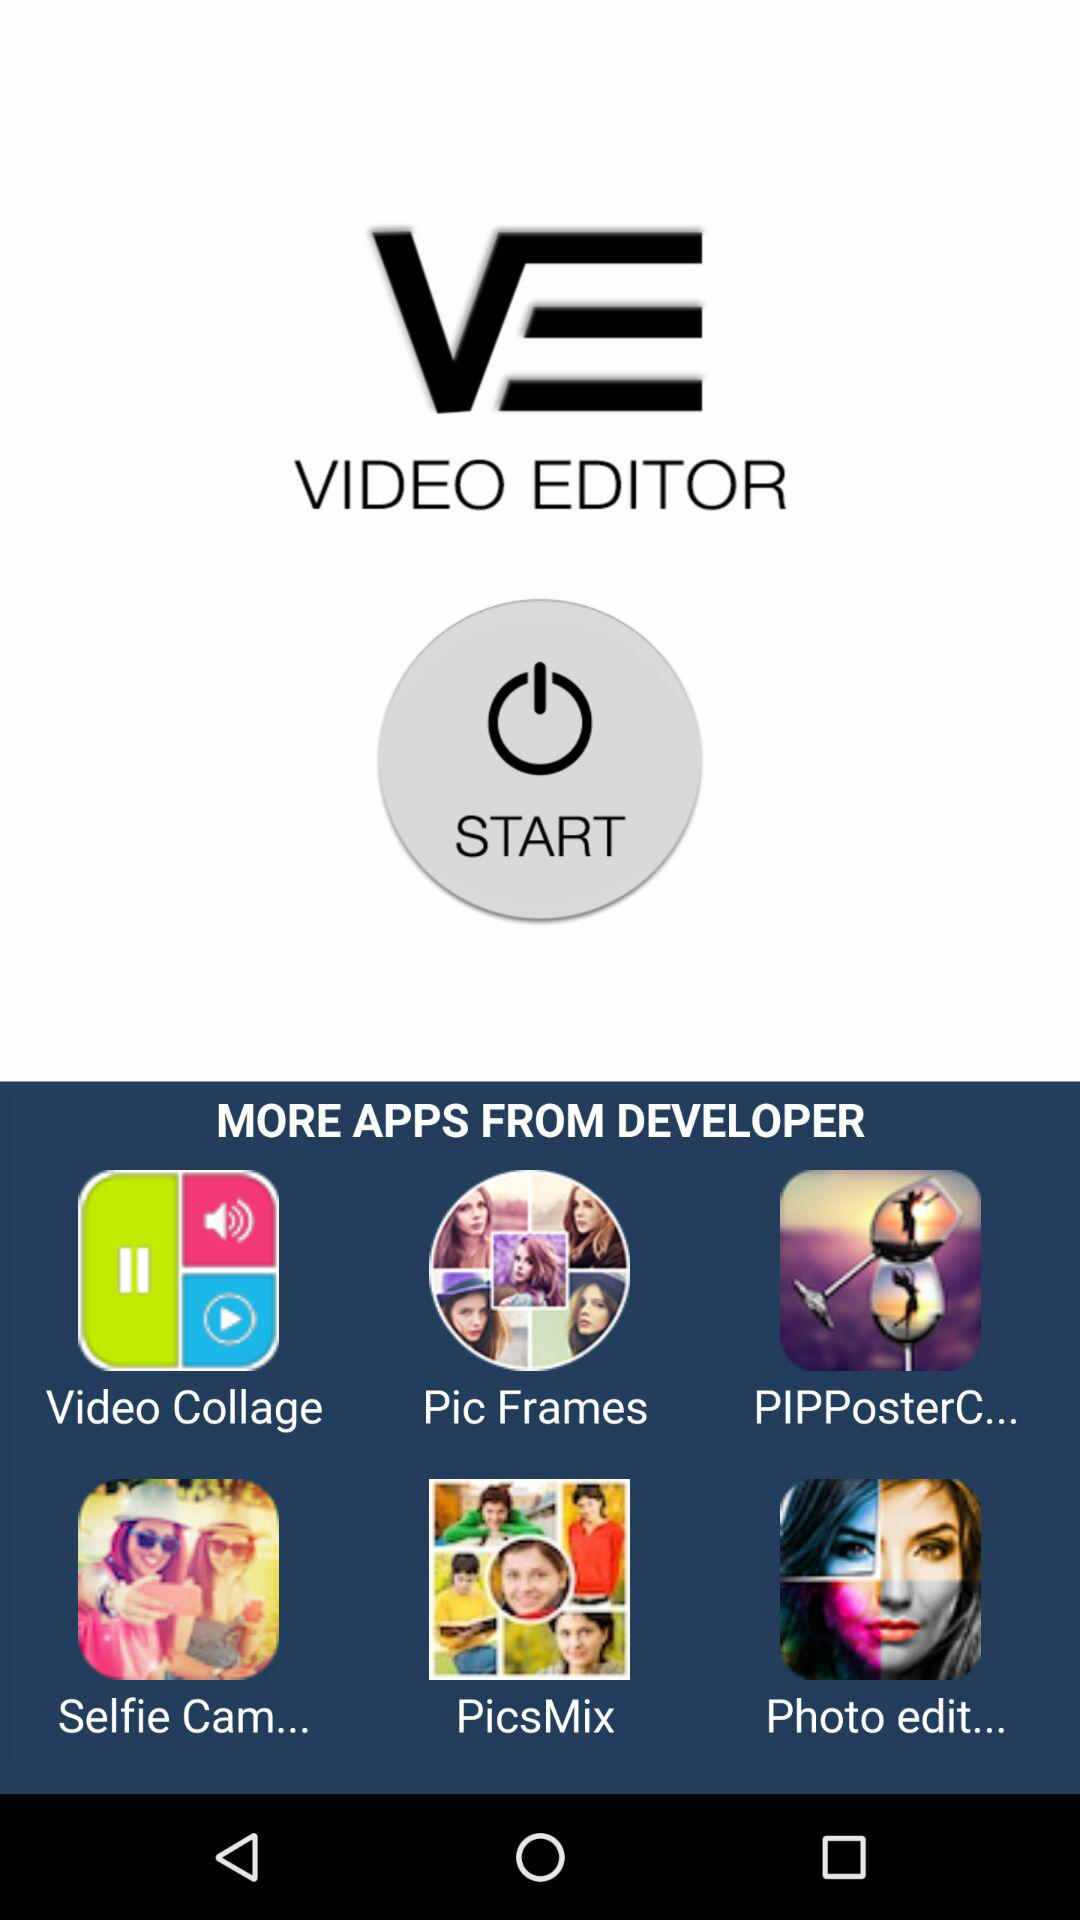What is the application name? The application name is "VIDEO EDITOR". 